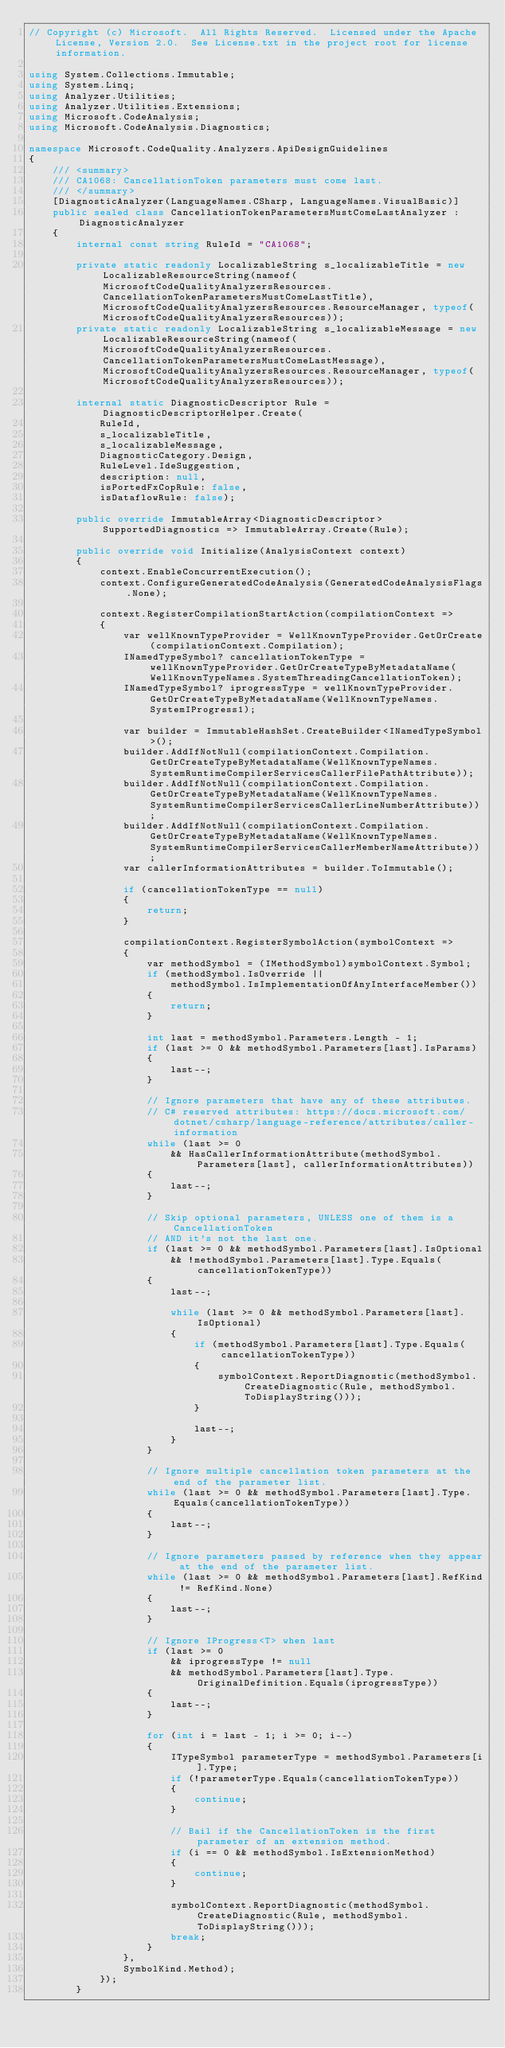Convert code to text. <code><loc_0><loc_0><loc_500><loc_500><_C#_>// Copyright (c) Microsoft.  All Rights Reserved.  Licensed under the Apache License, Version 2.0.  See License.txt in the project root for license information.

using System.Collections.Immutable;
using System.Linq;
using Analyzer.Utilities;
using Analyzer.Utilities.Extensions;
using Microsoft.CodeAnalysis;
using Microsoft.CodeAnalysis.Diagnostics;

namespace Microsoft.CodeQuality.Analyzers.ApiDesignGuidelines
{
    /// <summary>
    /// CA1068: CancellationToken parameters must come last.
    /// </summary>
    [DiagnosticAnalyzer(LanguageNames.CSharp, LanguageNames.VisualBasic)]
    public sealed class CancellationTokenParametersMustComeLastAnalyzer : DiagnosticAnalyzer
    {
        internal const string RuleId = "CA1068";

        private static readonly LocalizableString s_localizableTitle = new LocalizableResourceString(nameof(MicrosoftCodeQualityAnalyzersResources.CancellationTokenParametersMustComeLastTitle), MicrosoftCodeQualityAnalyzersResources.ResourceManager, typeof(MicrosoftCodeQualityAnalyzersResources));
        private static readonly LocalizableString s_localizableMessage = new LocalizableResourceString(nameof(MicrosoftCodeQualityAnalyzersResources.CancellationTokenParametersMustComeLastMessage), MicrosoftCodeQualityAnalyzersResources.ResourceManager, typeof(MicrosoftCodeQualityAnalyzersResources));

        internal static DiagnosticDescriptor Rule = DiagnosticDescriptorHelper.Create(
            RuleId,
            s_localizableTitle,
            s_localizableMessage,
            DiagnosticCategory.Design,
            RuleLevel.IdeSuggestion,
            description: null,
            isPortedFxCopRule: false,
            isDataflowRule: false);

        public override ImmutableArray<DiagnosticDescriptor> SupportedDiagnostics => ImmutableArray.Create(Rule);

        public override void Initialize(AnalysisContext context)
        {
            context.EnableConcurrentExecution();
            context.ConfigureGeneratedCodeAnalysis(GeneratedCodeAnalysisFlags.None);

            context.RegisterCompilationStartAction(compilationContext =>
            {
                var wellKnownTypeProvider = WellKnownTypeProvider.GetOrCreate(compilationContext.Compilation);
                INamedTypeSymbol? cancellationTokenType = wellKnownTypeProvider.GetOrCreateTypeByMetadataName(WellKnownTypeNames.SystemThreadingCancellationToken);
                INamedTypeSymbol? iprogressType = wellKnownTypeProvider.GetOrCreateTypeByMetadataName(WellKnownTypeNames.SystemIProgress1);

                var builder = ImmutableHashSet.CreateBuilder<INamedTypeSymbol>();
                builder.AddIfNotNull(compilationContext.Compilation.GetOrCreateTypeByMetadataName(WellKnownTypeNames.SystemRuntimeCompilerServicesCallerFilePathAttribute));
                builder.AddIfNotNull(compilationContext.Compilation.GetOrCreateTypeByMetadataName(WellKnownTypeNames.SystemRuntimeCompilerServicesCallerLineNumberAttribute));
                builder.AddIfNotNull(compilationContext.Compilation.GetOrCreateTypeByMetadataName(WellKnownTypeNames.SystemRuntimeCompilerServicesCallerMemberNameAttribute));
                var callerInformationAttributes = builder.ToImmutable();

                if (cancellationTokenType == null)
                {
                    return;
                }

                compilationContext.RegisterSymbolAction(symbolContext =>
                {
                    var methodSymbol = (IMethodSymbol)symbolContext.Symbol;
                    if (methodSymbol.IsOverride ||
                        methodSymbol.IsImplementationOfAnyInterfaceMember())
                    {
                        return;
                    }

                    int last = methodSymbol.Parameters.Length - 1;
                    if (last >= 0 && methodSymbol.Parameters[last].IsParams)
                    {
                        last--;
                    }

                    // Ignore parameters that have any of these attributes.
                    // C# reserved attributes: https://docs.microsoft.com/dotnet/csharp/language-reference/attributes/caller-information
                    while (last >= 0
                        && HasCallerInformationAttribute(methodSymbol.Parameters[last], callerInformationAttributes))
                    {
                        last--;
                    }

                    // Skip optional parameters, UNLESS one of them is a CancellationToken
                    // AND it's not the last one.
                    if (last >= 0 && methodSymbol.Parameters[last].IsOptional
                        && !methodSymbol.Parameters[last].Type.Equals(cancellationTokenType))
                    {
                        last--;

                        while (last >= 0 && methodSymbol.Parameters[last].IsOptional)
                        {
                            if (methodSymbol.Parameters[last].Type.Equals(cancellationTokenType))
                            {
                                symbolContext.ReportDiagnostic(methodSymbol.CreateDiagnostic(Rule, methodSymbol.ToDisplayString()));
                            }

                            last--;
                        }
                    }

                    // Ignore multiple cancellation token parameters at the end of the parameter list.
                    while (last >= 0 && methodSymbol.Parameters[last].Type.Equals(cancellationTokenType))
                    {
                        last--;
                    }

                    // Ignore parameters passed by reference when they appear at the end of the parameter list.
                    while (last >= 0 && methodSymbol.Parameters[last].RefKind != RefKind.None)
                    {
                        last--;
                    }

                    // Ignore IProgress<T> when last
                    if (last >= 0
                        && iprogressType != null
                        && methodSymbol.Parameters[last].Type.OriginalDefinition.Equals(iprogressType))
                    {
                        last--;
                    }

                    for (int i = last - 1; i >= 0; i--)
                    {
                        ITypeSymbol parameterType = methodSymbol.Parameters[i].Type;
                        if (!parameterType.Equals(cancellationTokenType))
                        {
                            continue;
                        }

                        // Bail if the CancellationToken is the first parameter of an extension method.
                        if (i == 0 && methodSymbol.IsExtensionMethod)
                        {
                            continue;
                        }

                        symbolContext.ReportDiagnostic(methodSymbol.CreateDiagnostic(Rule, methodSymbol.ToDisplayString()));
                        break;
                    }
                },
                SymbolKind.Method);
            });
        }
</code> 